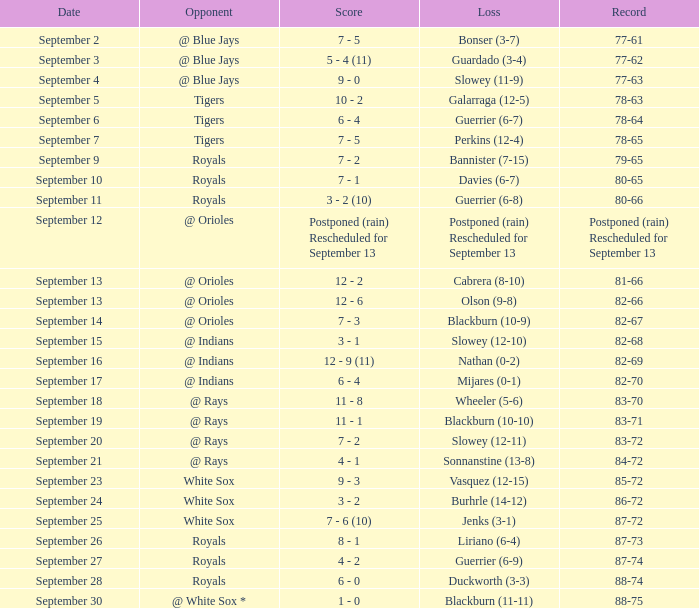What opponnent has a record of 82-68? @ Indians. 